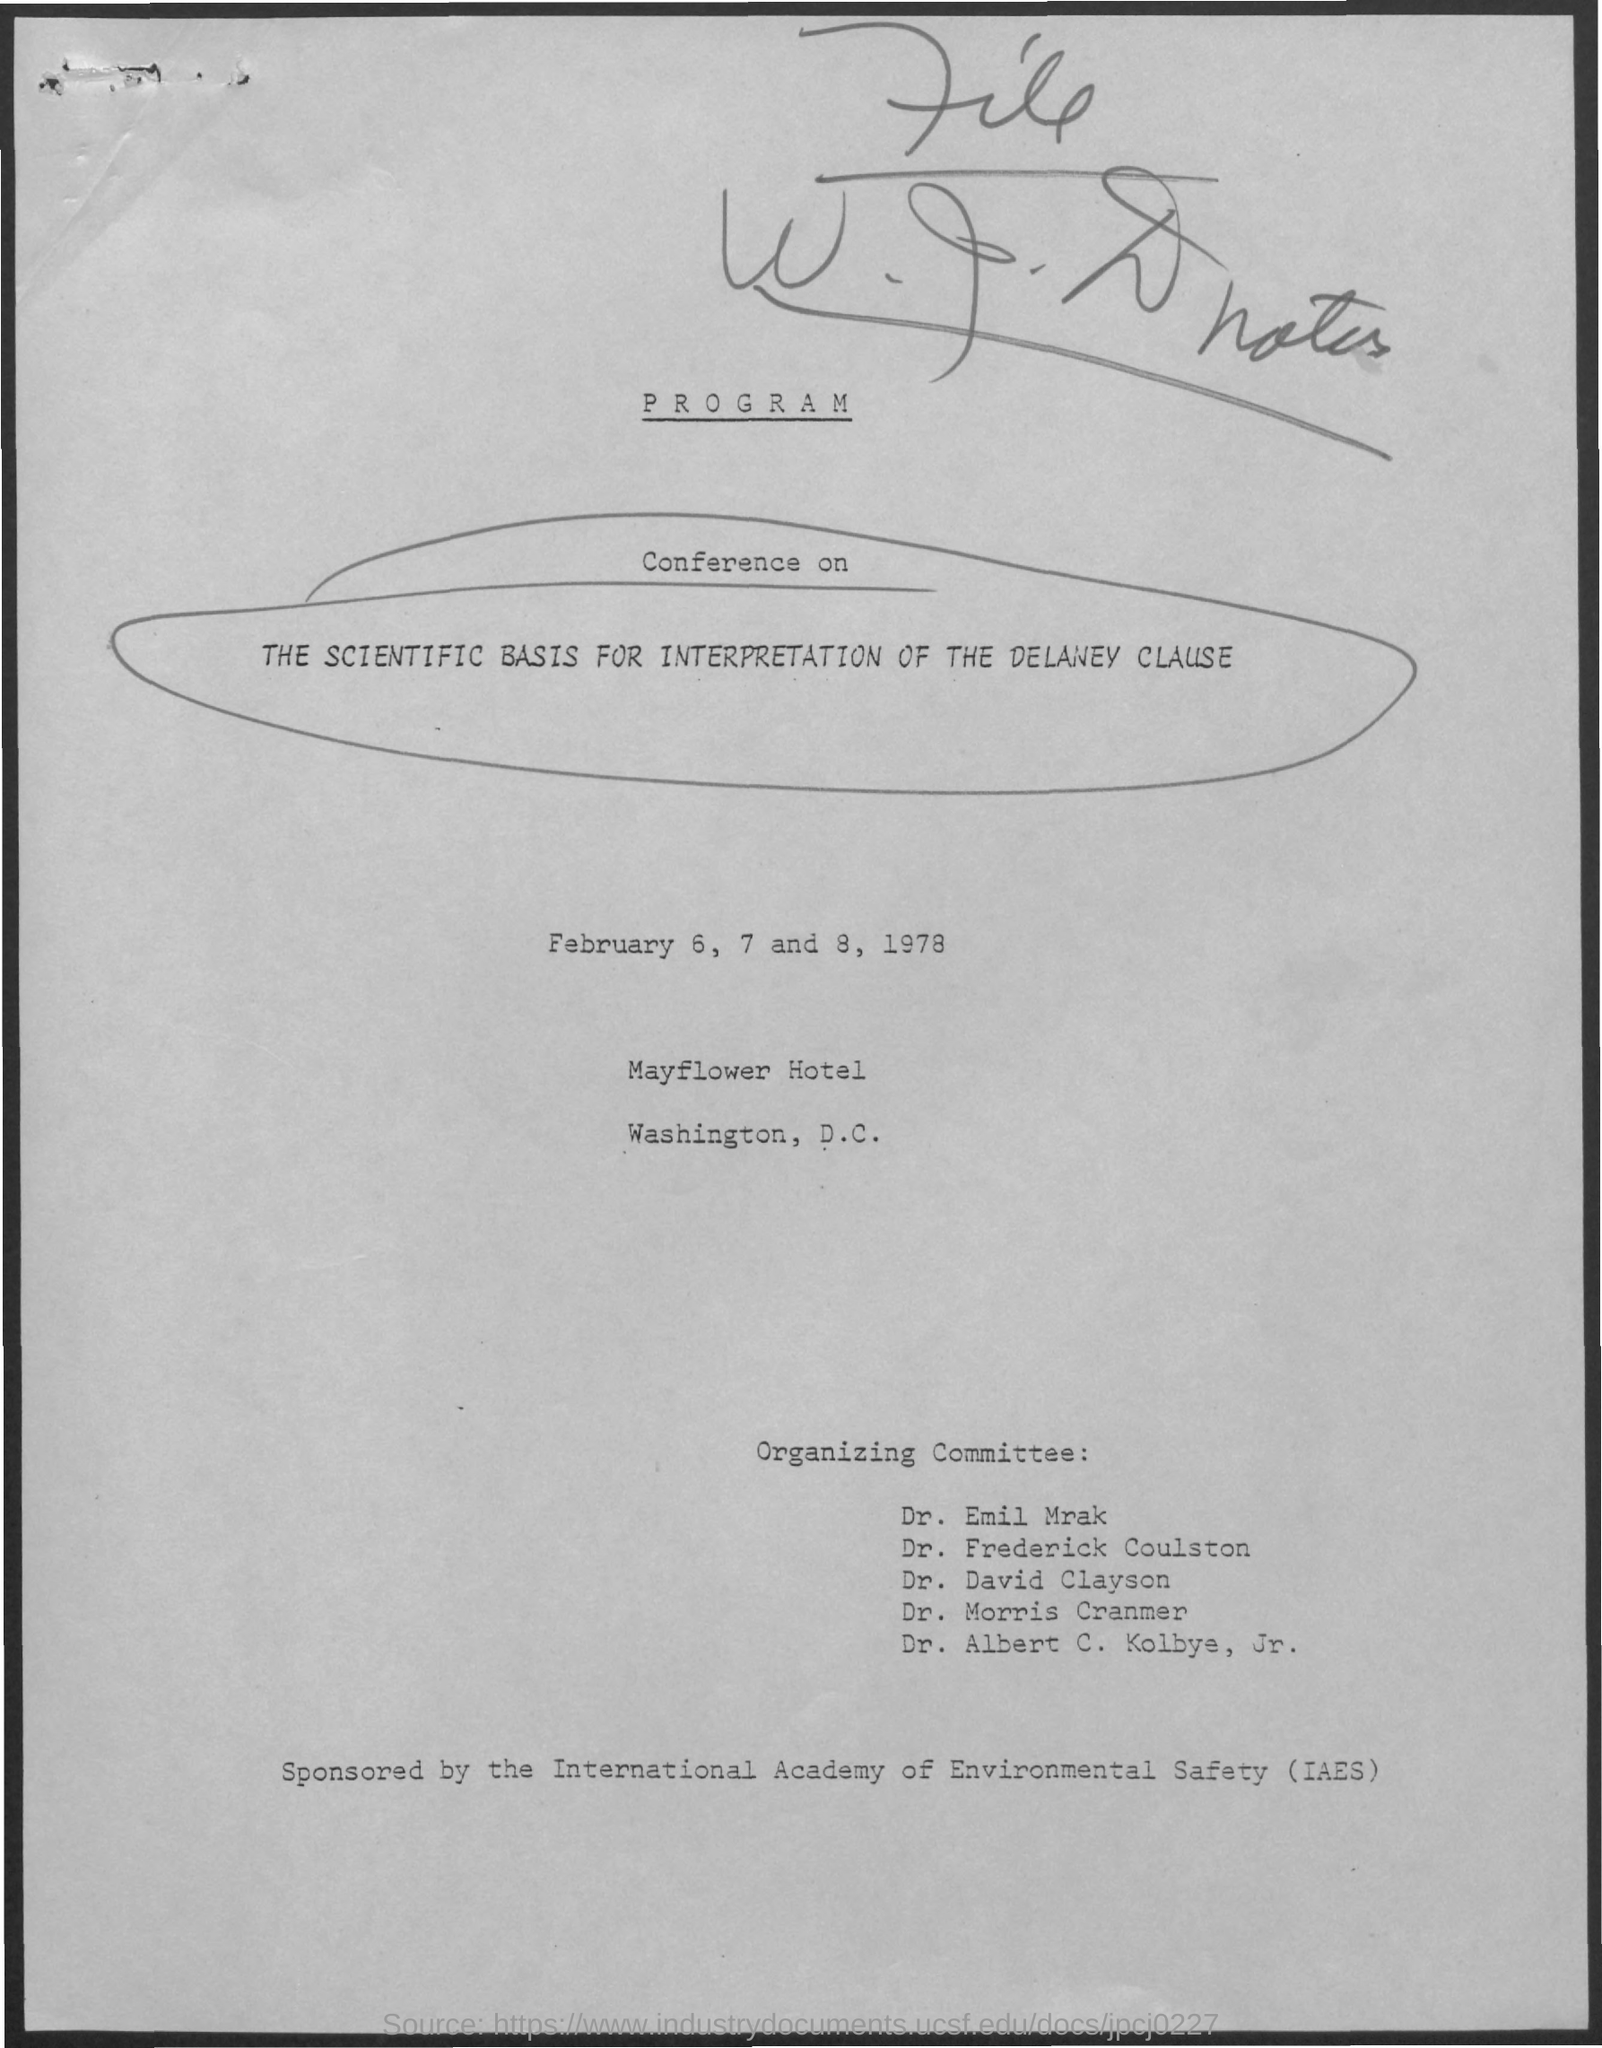Highlight a few significant elements in this photo. The title of the document is Program. The conference will take place on February 6, 7, and 8, 1978. 